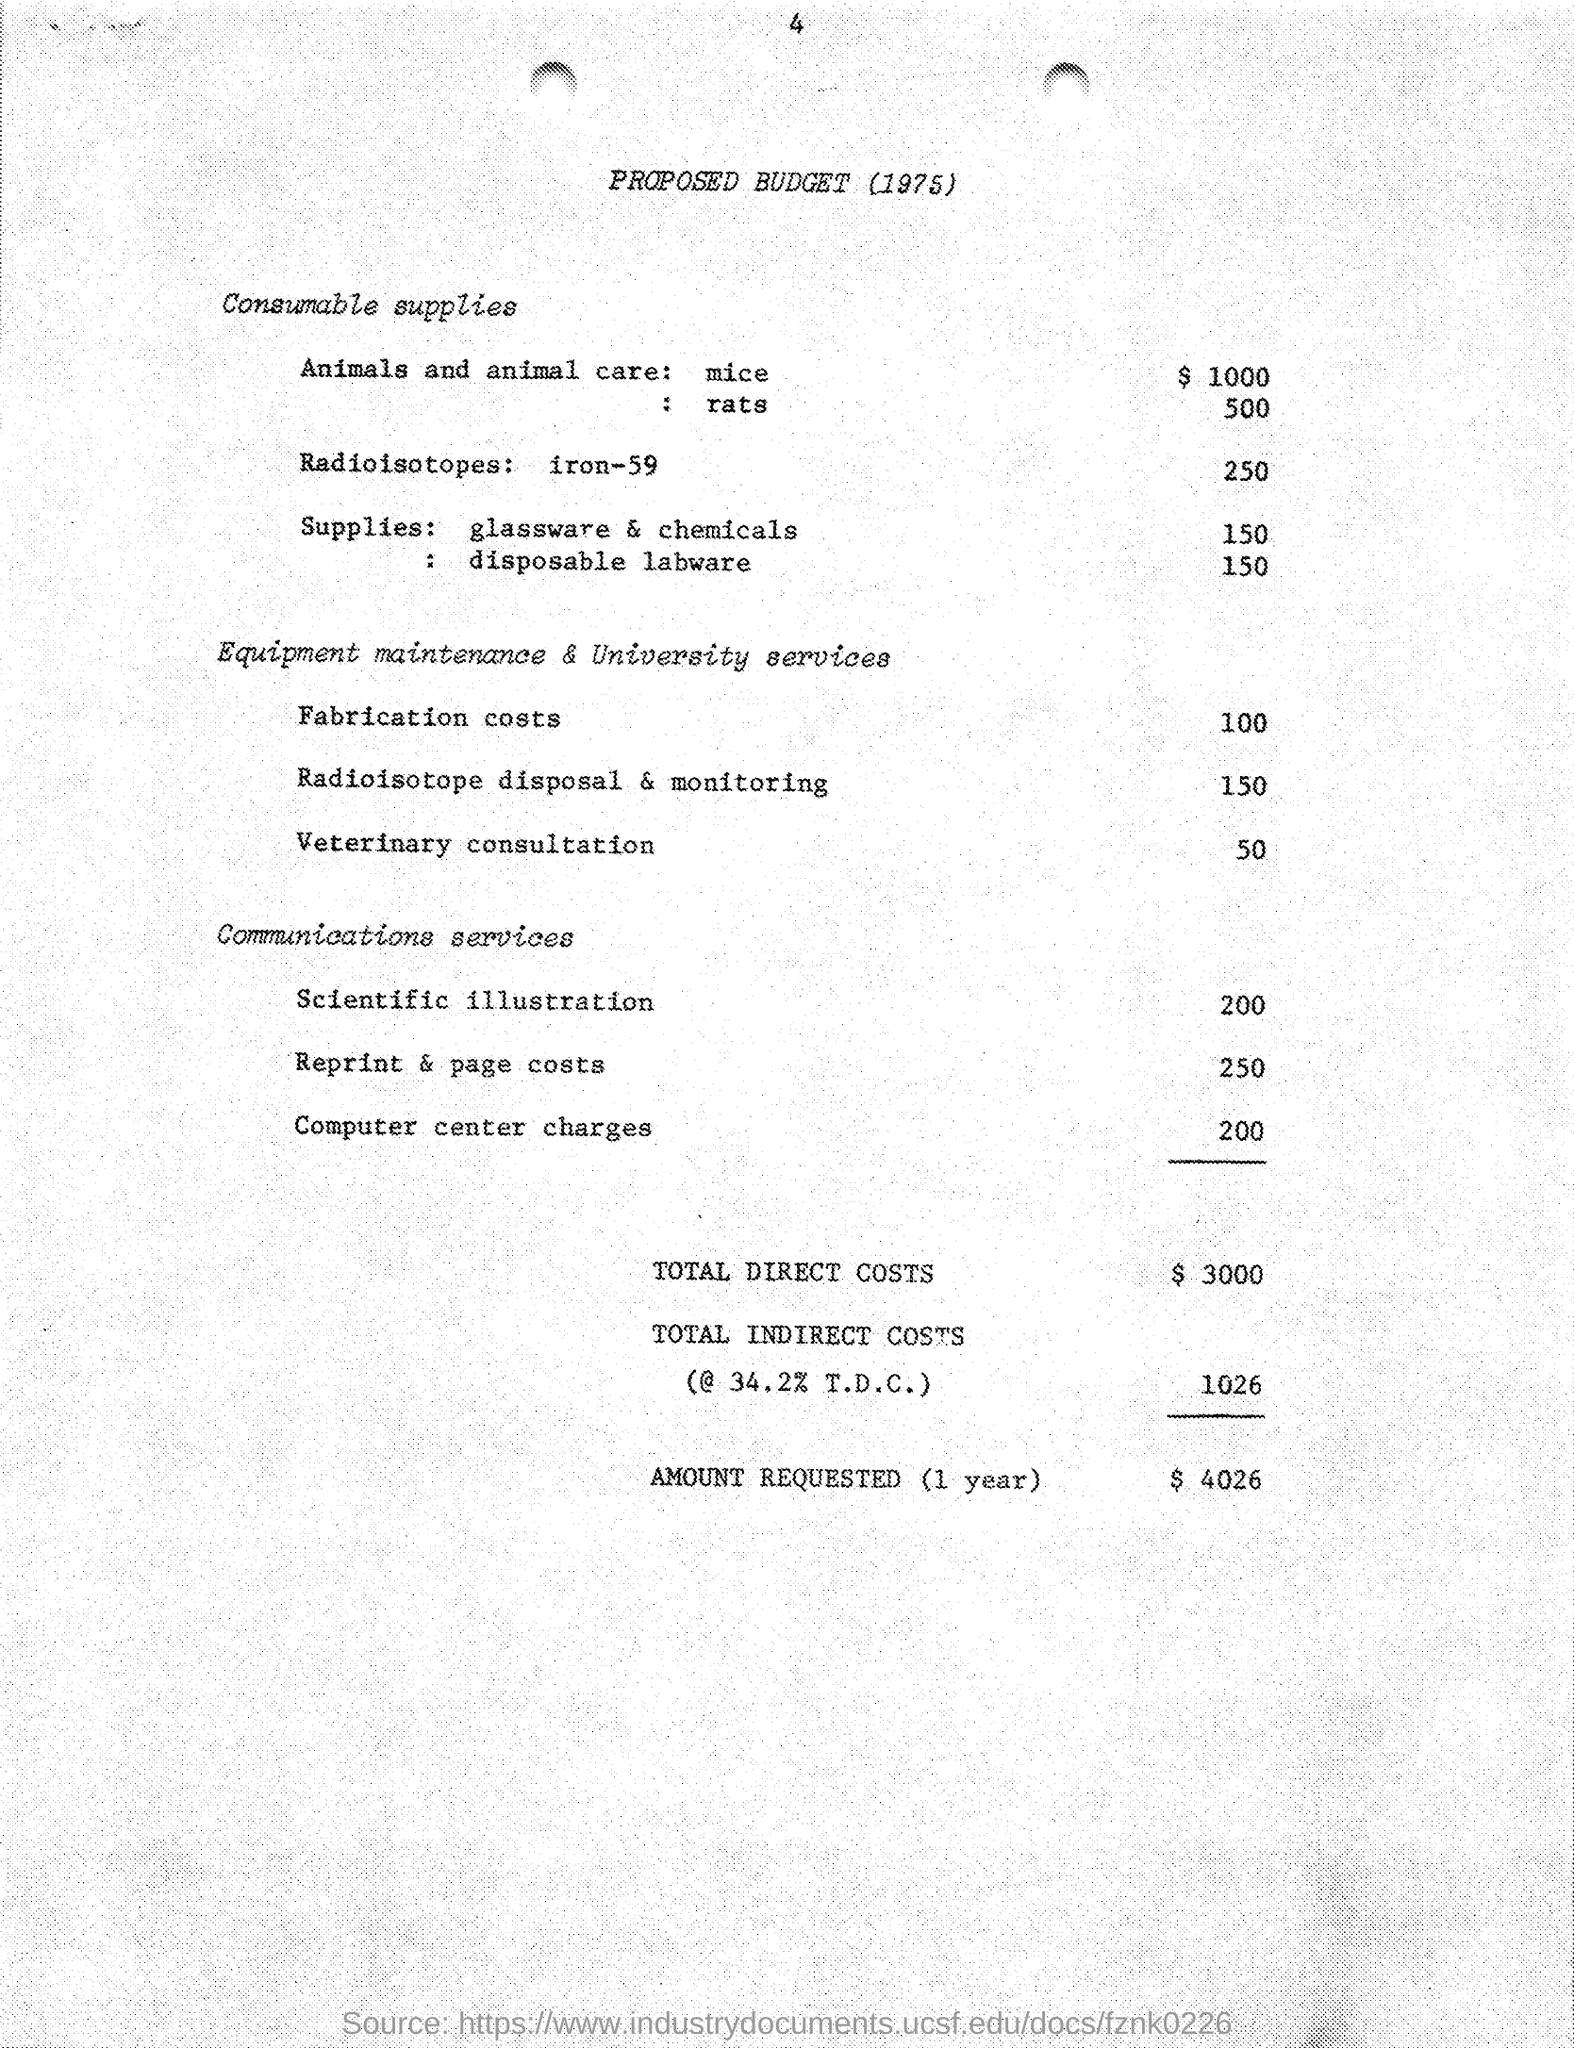What is the year of the proposed budget ?
Give a very brief answer. 1975. What is the amount given for animals and animals care (rats) in the proposed budget ?
Give a very brief answer. 500. What is the amount given for animals and animals care (mice) in the proposed budget ?
Ensure brevity in your answer.  $ 1000. What is the amount given for radioisotopes: iron -59 in the proposed budget ?
Make the answer very short. 250. What is the amount given for fabrication costs in the proposed budget ?
Provide a succinct answer. 100. What is the amount  given for veterinary consultation in the proposed budget ?
Provide a succinct answer. 50. What is the amount of total direct costs mentioned in the given budget ?
Provide a short and direct response. 3000. What is the amount of total indirect costs mentioned in the given budget ?
Offer a very short reply. 1026. What is the value of amount requested (1 year) as mentioned in the proposed budget ?
Make the answer very short. $ 4026. What is the amount given for reprint & page costs as mentioned in the proposed budget ?
Keep it short and to the point. 250. 